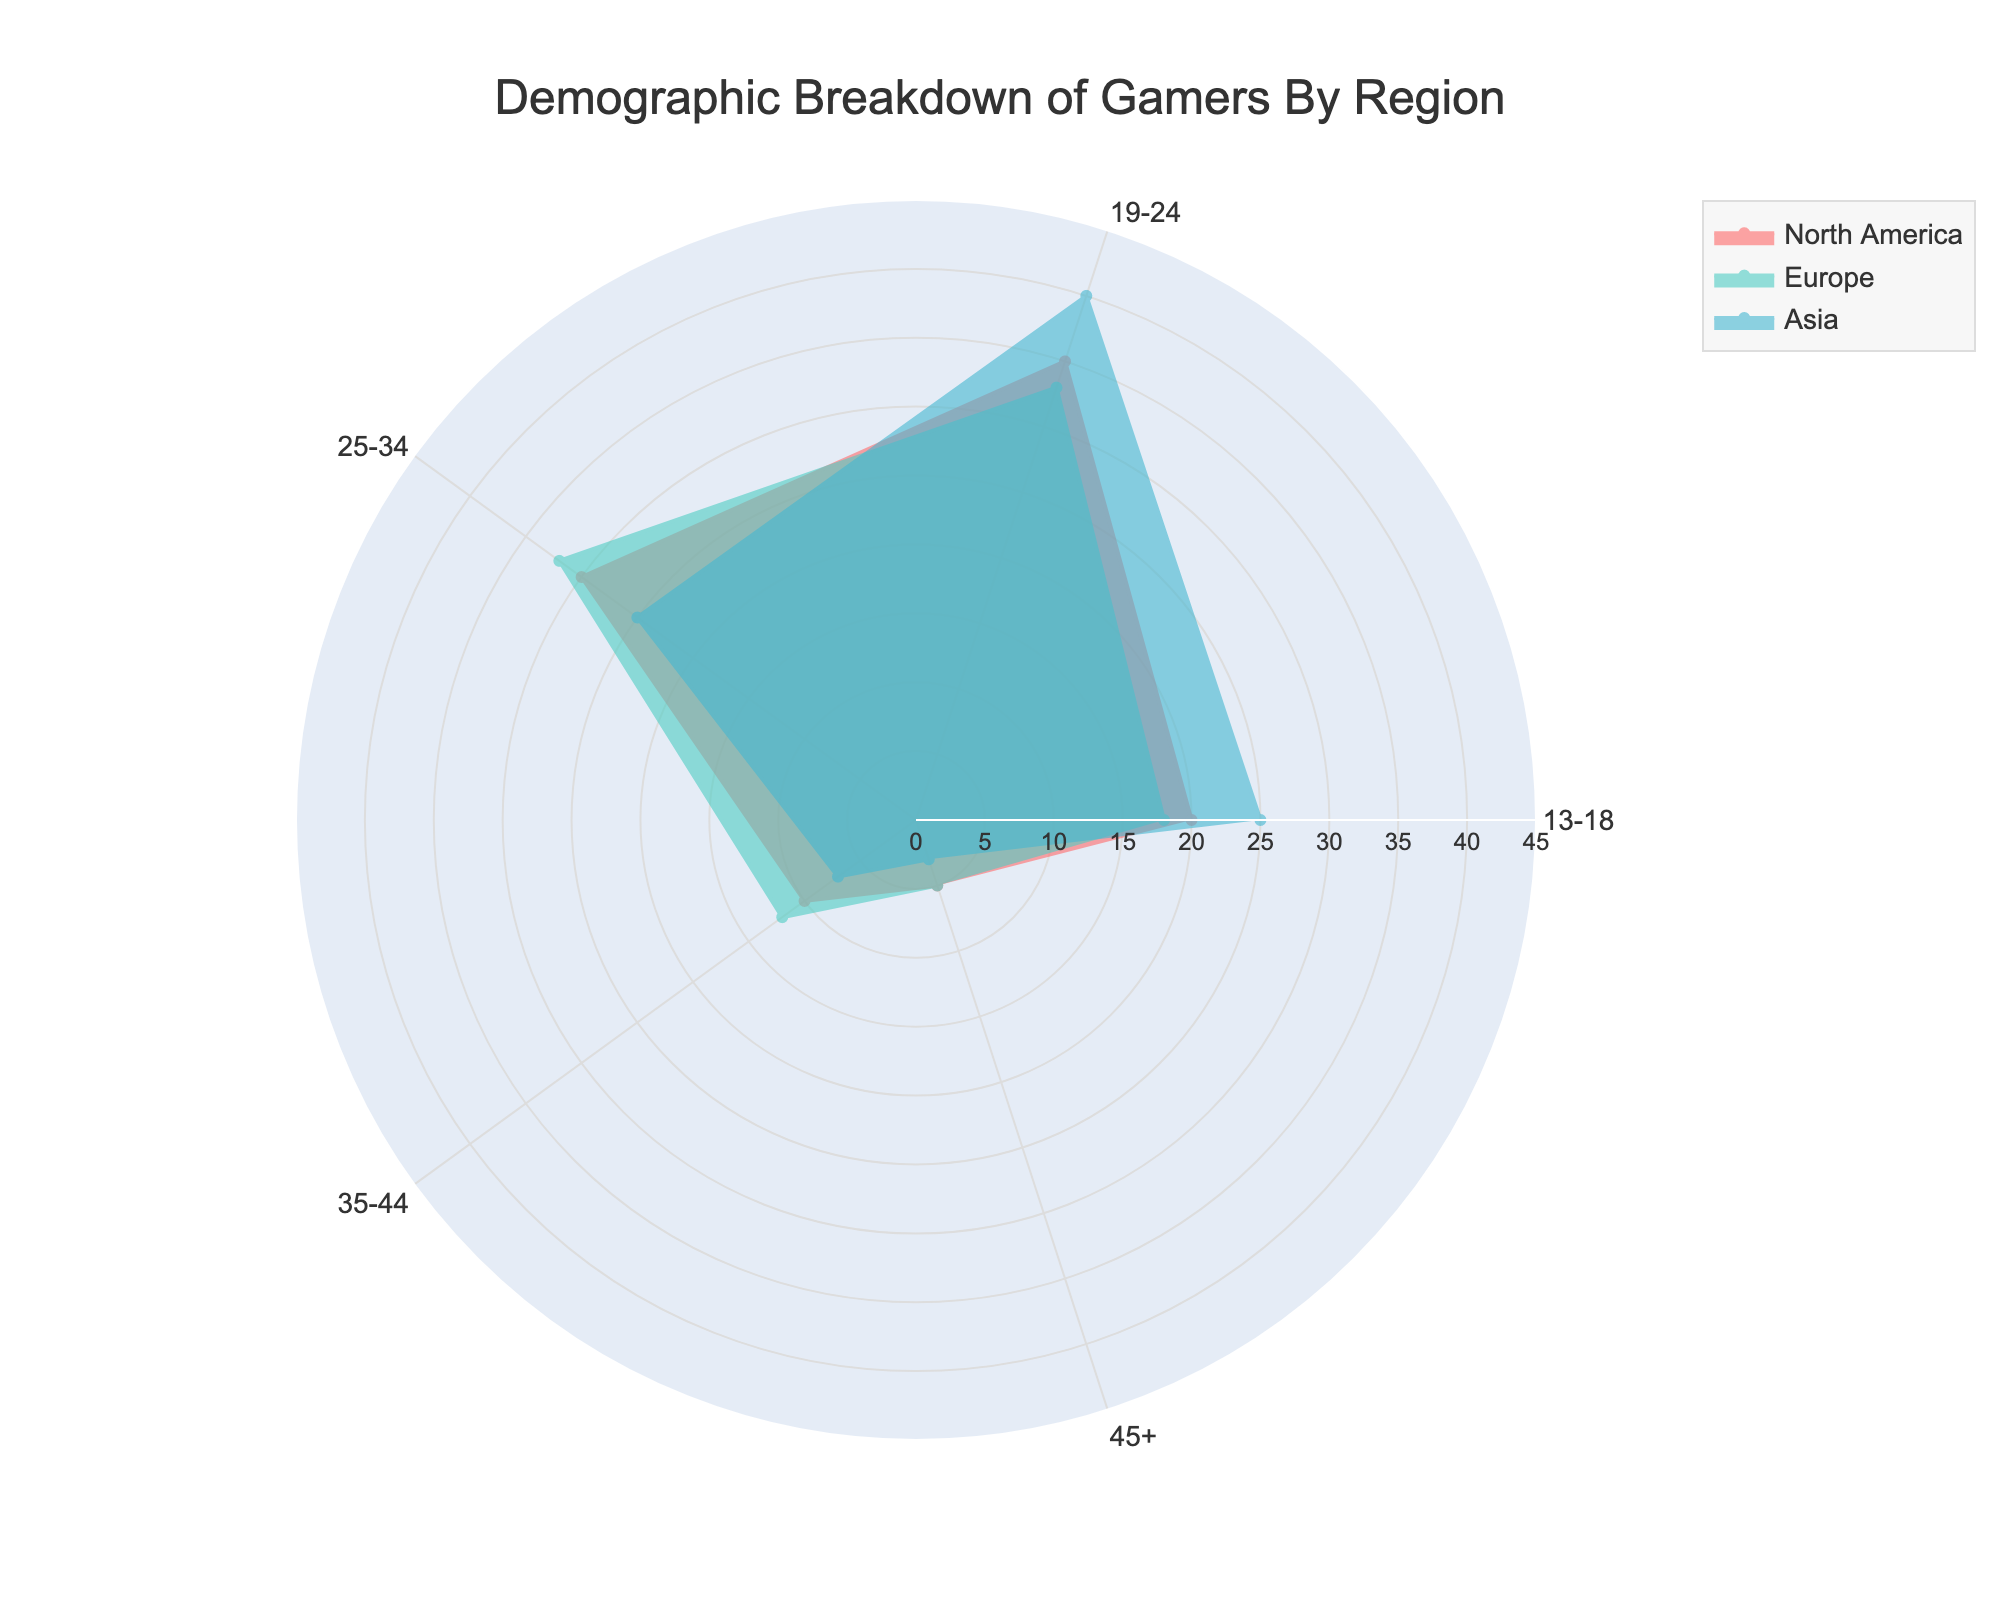What region has the highest percentage of gamers in the 19-24 age group? Looking at the lines for each region in the radar chart, Asia has the highest percentage of gamers in the 19-24 age group with 40%.
Answer: Asia What is the percentage of gamers aged 25-34 in North America? By referring to the node on the radar chart for North America corresponding to the 25-34 age group, you can see it reaches 30%.
Answer: 30% Which region has the least percentage of gamers aged 45+? Observing the lines for each region in the radar chart, you can see that Asia has the least percentage with 3%.
Answer: Asia How much higher is the percentage of gamers aged 13-18 in Asia compared to Europe? Asia has 25% and Europe has 18% for the 13-18 age group. So, 25% - 18% gives a difference of 7%.
Answer: 7% Among the 35-44 age group, is there any region where the percentage of gamers is less than 10%? By inspecting the radar chart, only the line for Asia in the 35-44 age group is below 10%, specifically at 7%.
Answer: Yes Which age group shows the most substantial difference between Europe and North America? Comparing the chart for both Europe and North America, the most significant difference is in the 25-34 age group with Europe at 32% and North America at 30%, giving a 2% difference.
Answer: 25-34 What is the average percentage of gamers aged 35-44 across all three regions? Adding the percentages for gamers aged 35-44 in North America (10%), Europe (12%), and Asia (7%) gives 10 + 12 + 7 = 29. Dividing by 3 regions, the average is 29 / 3 = 9.67%.
Answer: 9.67% In which region do gamers aged 19-24 represent the largest proportion of the total gaming population? The radar chart shows that Asia has the highest percentage of gamers in the 19-24 age group at 40%.
Answer: Asia 